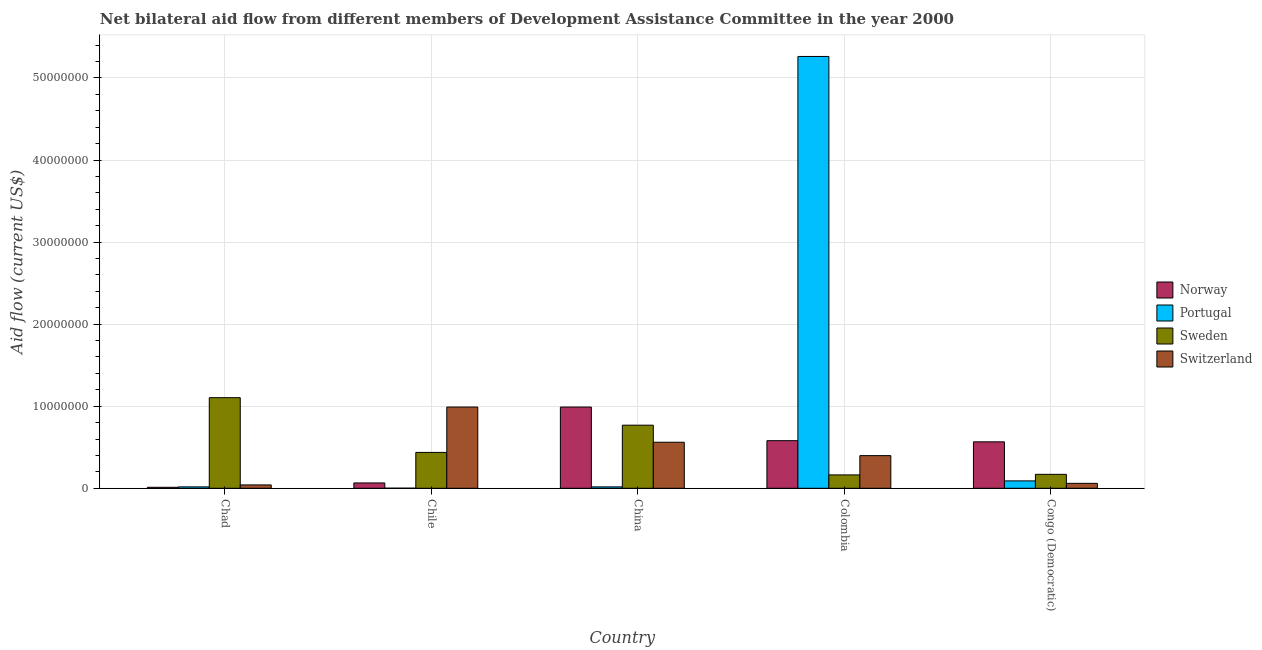How many different coloured bars are there?
Ensure brevity in your answer.  4. How many groups of bars are there?
Your answer should be very brief. 5. Are the number of bars on each tick of the X-axis equal?
Provide a short and direct response. Yes. How many bars are there on the 3rd tick from the right?
Your response must be concise. 4. What is the label of the 3rd group of bars from the left?
Offer a very short reply. China. What is the amount of aid given by portugal in Congo (Democratic)?
Your answer should be very brief. 9.00e+05. Across all countries, what is the maximum amount of aid given by sweden?
Ensure brevity in your answer.  1.10e+07. Across all countries, what is the minimum amount of aid given by switzerland?
Your answer should be compact. 4.10e+05. In which country was the amount of aid given by norway maximum?
Make the answer very short. China. In which country was the amount of aid given by switzerland minimum?
Ensure brevity in your answer.  Chad. What is the total amount of aid given by portugal in the graph?
Provide a succinct answer. 5.39e+07. What is the difference between the amount of aid given by norway in Chile and that in China?
Your answer should be very brief. -9.25e+06. What is the difference between the amount of aid given by norway in Chile and the amount of aid given by switzerland in Colombia?
Offer a terse response. -3.33e+06. What is the average amount of aid given by norway per country?
Provide a short and direct response. 4.43e+06. What is the difference between the amount of aid given by switzerland and amount of aid given by norway in China?
Your answer should be very brief. -4.29e+06. In how many countries, is the amount of aid given by switzerland greater than 22000000 US$?
Your answer should be compact. 0. What is the ratio of the amount of aid given by sweden in Chad to that in China?
Offer a very short reply. 1.44. Is the amount of aid given by portugal in Chad less than that in Congo (Democratic)?
Make the answer very short. Yes. Is the difference between the amount of aid given by portugal in Colombia and Congo (Democratic) greater than the difference between the amount of aid given by sweden in Colombia and Congo (Democratic)?
Ensure brevity in your answer.  Yes. What is the difference between the highest and the second highest amount of aid given by portugal?
Provide a short and direct response. 5.17e+07. What is the difference between the highest and the lowest amount of aid given by portugal?
Provide a short and direct response. 5.26e+07. In how many countries, is the amount of aid given by norway greater than the average amount of aid given by norway taken over all countries?
Give a very brief answer. 3. Is the sum of the amount of aid given by sweden in Chad and Congo (Democratic) greater than the maximum amount of aid given by norway across all countries?
Provide a succinct answer. Yes. What does the 4th bar from the left in China represents?
Provide a succinct answer. Switzerland. Is it the case that in every country, the sum of the amount of aid given by norway and amount of aid given by portugal is greater than the amount of aid given by sweden?
Keep it short and to the point. No. How many bars are there?
Give a very brief answer. 20. How many countries are there in the graph?
Ensure brevity in your answer.  5. Are the values on the major ticks of Y-axis written in scientific E-notation?
Ensure brevity in your answer.  No. Does the graph contain any zero values?
Ensure brevity in your answer.  No. What is the title of the graph?
Ensure brevity in your answer.  Net bilateral aid flow from different members of Development Assistance Committee in the year 2000. What is the label or title of the Y-axis?
Make the answer very short. Aid flow (current US$). What is the Aid flow (current US$) of Norway in Chad?
Ensure brevity in your answer.  1.20e+05. What is the Aid flow (current US$) in Portugal in Chad?
Offer a very short reply. 1.70e+05. What is the Aid flow (current US$) in Sweden in Chad?
Provide a succinct answer. 1.10e+07. What is the Aid flow (current US$) of Switzerland in Chad?
Your answer should be compact. 4.10e+05. What is the Aid flow (current US$) of Norway in Chile?
Provide a short and direct response. 6.50e+05. What is the Aid flow (current US$) in Portugal in Chile?
Your response must be concise. 10000. What is the Aid flow (current US$) of Sweden in Chile?
Give a very brief answer. 4.37e+06. What is the Aid flow (current US$) of Switzerland in Chile?
Offer a very short reply. 9.90e+06. What is the Aid flow (current US$) of Norway in China?
Your answer should be compact. 9.90e+06. What is the Aid flow (current US$) in Portugal in China?
Your response must be concise. 1.70e+05. What is the Aid flow (current US$) of Sweden in China?
Your answer should be compact. 7.69e+06. What is the Aid flow (current US$) of Switzerland in China?
Your response must be concise. 5.61e+06. What is the Aid flow (current US$) of Norway in Colombia?
Offer a very short reply. 5.80e+06. What is the Aid flow (current US$) of Portugal in Colombia?
Give a very brief answer. 5.26e+07. What is the Aid flow (current US$) in Sweden in Colombia?
Offer a very short reply. 1.63e+06. What is the Aid flow (current US$) of Switzerland in Colombia?
Offer a very short reply. 3.98e+06. What is the Aid flow (current US$) in Norway in Congo (Democratic)?
Provide a short and direct response. 5.66e+06. What is the Aid flow (current US$) of Sweden in Congo (Democratic)?
Ensure brevity in your answer.  1.70e+06. Across all countries, what is the maximum Aid flow (current US$) in Norway?
Provide a short and direct response. 9.90e+06. Across all countries, what is the maximum Aid flow (current US$) of Portugal?
Provide a succinct answer. 5.26e+07. Across all countries, what is the maximum Aid flow (current US$) in Sweden?
Ensure brevity in your answer.  1.10e+07. Across all countries, what is the maximum Aid flow (current US$) of Switzerland?
Offer a very short reply. 9.90e+06. Across all countries, what is the minimum Aid flow (current US$) in Sweden?
Offer a very short reply. 1.63e+06. Across all countries, what is the minimum Aid flow (current US$) in Switzerland?
Make the answer very short. 4.10e+05. What is the total Aid flow (current US$) of Norway in the graph?
Your response must be concise. 2.21e+07. What is the total Aid flow (current US$) of Portugal in the graph?
Ensure brevity in your answer.  5.39e+07. What is the total Aid flow (current US$) of Sweden in the graph?
Give a very brief answer. 2.64e+07. What is the total Aid flow (current US$) of Switzerland in the graph?
Provide a succinct answer. 2.05e+07. What is the difference between the Aid flow (current US$) in Norway in Chad and that in Chile?
Your response must be concise. -5.30e+05. What is the difference between the Aid flow (current US$) in Portugal in Chad and that in Chile?
Ensure brevity in your answer.  1.60e+05. What is the difference between the Aid flow (current US$) of Sweden in Chad and that in Chile?
Your answer should be compact. 6.67e+06. What is the difference between the Aid flow (current US$) of Switzerland in Chad and that in Chile?
Your response must be concise. -9.49e+06. What is the difference between the Aid flow (current US$) of Norway in Chad and that in China?
Provide a short and direct response. -9.78e+06. What is the difference between the Aid flow (current US$) of Sweden in Chad and that in China?
Your answer should be very brief. 3.35e+06. What is the difference between the Aid flow (current US$) in Switzerland in Chad and that in China?
Offer a very short reply. -5.20e+06. What is the difference between the Aid flow (current US$) in Norway in Chad and that in Colombia?
Make the answer very short. -5.68e+06. What is the difference between the Aid flow (current US$) of Portugal in Chad and that in Colombia?
Offer a terse response. -5.24e+07. What is the difference between the Aid flow (current US$) in Sweden in Chad and that in Colombia?
Offer a very short reply. 9.41e+06. What is the difference between the Aid flow (current US$) of Switzerland in Chad and that in Colombia?
Your answer should be compact. -3.57e+06. What is the difference between the Aid flow (current US$) of Norway in Chad and that in Congo (Democratic)?
Your answer should be compact. -5.54e+06. What is the difference between the Aid flow (current US$) in Portugal in Chad and that in Congo (Democratic)?
Provide a short and direct response. -7.30e+05. What is the difference between the Aid flow (current US$) in Sweden in Chad and that in Congo (Democratic)?
Offer a very short reply. 9.34e+06. What is the difference between the Aid flow (current US$) in Switzerland in Chad and that in Congo (Democratic)?
Make the answer very short. -1.90e+05. What is the difference between the Aid flow (current US$) of Norway in Chile and that in China?
Provide a short and direct response. -9.25e+06. What is the difference between the Aid flow (current US$) in Sweden in Chile and that in China?
Your response must be concise. -3.32e+06. What is the difference between the Aid flow (current US$) of Switzerland in Chile and that in China?
Your answer should be very brief. 4.29e+06. What is the difference between the Aid flow (current US$) of Norway in Chile and that in Colombia?
Your answer should be compact. -5.15e+06. What is the difference between the Aid flow (current US$) of Portugal in Chile and that in Colombia?
Ensure brevity in your answer.  -5.26e+07. What is the difference between the Aid flow (current US$) of Sweden in Chile and that in Colombia?
Give a very brief answer. 2.74e+06. What is the difference between the Aid flow (current US$) in Switzerland in Chile and that in Colombia?
Provide a short and direct response. 5.92e+06. What is the difference between the Aid flow (current US$) in Norway in Chile and that in Congo (Democratic)?
Your answer should be compact. -5.01e+06. What is the difference between the Aid flow (current US$) of Portugal in Chile and that in Congo (Democratic)?
Give a very brief answer. -8.90e+05. What is the difference between the Aid flow (current US$) of Sweden in Chile and that in Congo (Democratic)?
Your response must be concise. 2.67e+06. What is the difference between the Aid flow (current US$) in Switzerland in Chile and that in Congo (Democratic)?
Keep it short and to the point. 9.30e+06. What is the difference between the Aid flow (current US$) of Norway in China and that in Colombia?
Offer a terse response. 4.10e+06. What is the difference between the Aid flow (current US$) of Portugal in China and that in Colombia?
Your response must be concise. -5.24e+07. What is the difference between the Aid flow (current US$) in Sweden in China and that in Colombia?
Provide a succinct answer. 6.06e+06. What is the difference between the Aid flow (current US$) in Switzerland in China and that in Colombia?
Provide a succinct answer. 1.63e+06. What is the difference between the Aid flow (current US$) of Norway in China and that in Congo (Democratic)?
Give a very brief answer. 4.24e+06. What is the difference between the Aid flow (current US$) of Portugal in China and that in Congo (Democratic)?
Offer a very short reply. -7.30e+05. What is the difference between the Aid flow (current US$) in Sweden in China and that in Congo (Democratic)?
Keep it short and to the point. 5.99e+06. What is the difference between the Aid flow (current US$) in Switzerland in China and that in Congo (Democratic)?
Your answer should be very brief. 5.01e+06. What is the difference between the Aid flow (current US$) of Portugal in Colombia and that in Congo (Democratic)?
Offer a very short reply. 5.17e+07. What is the difference between the Aid flow (current US$) in Switzerland in Colombia and that in Congo (Democratic)?
Keep it short and to the point. 3.38e+06. What is the difference between the Aid flow (current US$) in Norway in Chad and the Aid flow (current US$) in Portugal in Chile?
Give a very brief answer. 1.10e+05. What is the difference between the Aid flow (current US$) of Norway in Chad and the Aid flow (current US$) of Sweden in Chile?
Give a very brief answer. -4.25e+06. What is the difference between the Aid flow (current US$) in Norway in Chad and the Aid flow (current US$) in Switzerland in Chile?
Give a very brief answer. -9.78e+06. What is the difference between the Aid flow (current US$) of Portugal in Chad and the Aid flow (current US$) of Sweden in Chile?
Offer a terse response. -4.20e+06. What is the difference between the Aid flow (current US$) in Portugal in Chad and the Aid flow (current US$) in Switzerland in Chile?
Keep it short and to the point. -9.73e+06. What is the difference between the Aid flow (current US$) of Sweden in Chad and the Aid flow (current US$) of Switzerland in Chile?
Make the answer very short. 1.14e+06. What is the difference between the Aid flow (current US$) of Norway in Chad and the Aid flow (current US$) of Portugal in China?
Your answer should be very brief. -5.00e+04. What is the difference between the Aid flow (current US$) of Norway in Chad and the Aid flow (current US$) of Sweden in China?
Your answer should be compact. -7.57e+06. What is the difference between the Aid flow (current US$) of Norway in Chad and the Aid flow (current US$) of Switzerland in China?
Provide a short and direct response. -5.49e+06. What is the difference between the Aid flow (current US$) of Portugal in Chad and the Aid flow (current US$) of Sweden in China?
Your response must be concise. -7.52e+06. What is the difference between the Aid flow (current US$) of Portugal in Chad and the Aid flow (current US$) of Switzerland in China?
Provide a short and direct response. -5.44e+06. What is the difference between the Aid flow (current US$) in Sweden in Chad and the Aid flow (current US$) in Switzerland in China?
Make the answer very short. 5.43e+06. What is the difference between the Aid flow (current US$) in Norway in Chad and the Aid flow (current US$) in Portugal in Colombia?
Give a very brief answer. -5.25e+07. What is the difference between the Aid flow (current US$) of Norway in Chad and the Aid flow (current US$) of Sweden in Colombia?
Give a very brief answer. -1.51e+06. What is the difference between the Aid flow (current US$) of Norway in Chad and the Aid flow (current US$) of Switzerland in Colombia?
Your answer should be very brief. -3.86e+06. What is the difference between the Aid flow (current US$) of Portugal in Chad and the Aid flow (current US$) of Sweden in Colombia?
Give a very brief answer. -1.46e+06. What is the difference between the Aid flow (current US$) in Portugal in Chad and the Aid flow (current US$) in Switzerland in Colombia?
Your response must be concise. -3.81e+06. What is the difference between the Aid flow (current US$) of Sweden in Chad and the Aid flow (current US$) of Switzerland in Colombia?
Ensure brevity in your answer.  7.06e+06. What is the difference between the Aid flow (current US$) of Norway in Chad and the Aid flow (current US$) of Portugal in Congo (Democratic)?
Offer a terse response. -7.80e+05. What is the difference between the Aid flow (current US$) in Norway in Chad and the Aid flow (current US$) in Sweden in Congo (Democratic)?
Your response must be concise. -1.58e+06. What is the difference between the Aid flow (current US$) of Norway in Chad and the Aid flow (current US$) of Switzerland in Congo (Democratic)?
Make the answer very short. -4.80e+05. What is the difference between the Aid flow (current US$) of Portugal in Chad and the Aid flow (current US$) of Sweden in Congo (Democratic)?
Provide a short and direct response. -1.53e+06. What is the difference between the Aid flow (current US$) of Portugal in Chad and the Aid flow (current US$) of Switzerland in Congo (Democratic)?
Ensure brevity in your answer.  -4.30e+05. What is the difference between the Aid flow (current US$) of Sweden in Chad and the Aid flow (current US$) of Switzerland in Congo (Democratic)?
Your response must be concise. 1.04e+07. What is the difference between the Aid flow (current US$) in Norway in Chile and the Aid flow (current US$) in Portugal in China?
Ensure brevity in your answer.  4.80e+05. What is the difference between the Aid flow (current US$) of Norway in Chile and the Aid flow (current US$) of Sweden in China?
Provide a short and direct response. -7.04e+06. What is the difference between the Aid flow (current US$) in Norway in Chile and the Aid flow (current US$) in Switzerland in China?
Ensure brevity in your answer.  -4.96e+06. What is the difference between the Aid flow (current US$) of Portugal in Chile and the Aid flow (current US$) of Sweden in China?
Your response must be concise. -7.68e+06. What is the difference between the Aid flow (current US$) of Portugal in Chile and the Aid flow (current US$) of Switzerland in China?
Provide a short and direct response. -5.60e+06. What is the difference between the Aid flow (current US$) in Sweden in Chile and the Aid flow (current US$) in Switzerland in China?
Your answer should be very brief. -1.24e+06. What is the difference between the Aid flow (current US$) in Norway in Chile and the Aid flow (current US$) in Portugal in Colombia?
Provide a succinct answer. -5.20e+07. What is the difference between the Aid flow (current US$) of Norway in Chile and the Aid flow (current US$) of Sweden in Colombia?
Ensure brevity in your answer.  -9.80e+05. What is the difference between the Aid flow (current US$) in Norway in Chile and the Aid flow (current US$) in Switzerland in Colombia?
Ensure brevity in your answer.  -3.33e+06. What is the difference between the Aid flow (current US$) in Portugal in Chile and the Aid flow (current US$) in Sweden in Colombia?
Offer a very short reply. -1.62e+06. What is the difference between the Aid flow (current US$) in Portugal in Chile and the Aid flow (current US$) in Switzerland in Colombia?
Your answer should be compact. -3.97e+06. What is the difference between the Aid flow (current US$) of Norway in Chile and the Aid flow (current US$) of Portugal in Congo (Democratic)?
Give a very brief answer. -2.50e+05. What is the difference between the Aid flow (current US$) of Norway in Chile and the Aid flow (current US$) of Sweden in Congo (Democratic)?
Provide a short and direct response. -1.05e+06. What is the difference between the Aid flow (current US$) of Portugal in Chile and the Aid flow (current US$) of Sweden in Congo (Democratic)?
Give a very brief answer. -1.69e+06. What is the difference between the Aid flow (current US$) in Portugal in Chile and the Aid flow (current US$) in Switzerland in Congo (Democratic)?
Offer a terse response. -5.90e+05. What is the difference between the Aid flow (current US$) of Sweden in Chile and the Aid flow (current US$) of Switzerland in Congo (Democratic)?
Offer a very short reply. 3.77e+06. What is the difference between the Aid flow (current US$) in Norway in China and the Aid flow (current US$) in Portugal in Colombia?
Your answer should be very brief. -4.27e+07. What is the difference between the Aid flow (current US$) of Norway in China and the Aid flow (current US$) of Sweden in Colombia?
Your answer should be very brief. 8.27e+06. What is the difference between the Aid flow (current US$) in Norway in China and the Aid flow (current US$) in Switzerland in Colombia?
Your response must be concise. 5.92e+06. What is the difference between the Aid flow (current US$) of Portugal in China and the Aid flow (current US$) of Sweden in Colombia?
Make the answer very short. -1.46e+06. What is the difference between the Aid flow (current US$) of Portugal in China and the Aid flow (current US$) of Switzerland in Colombia?
Ensure brevity in your answer.  -3.81e+06. What is the difference between the Aid flow (current US$) of Sweden in China and the Aid flow (current US$) of Switzerland in Colombia?
Your answer should be very brief. 3.71e+06. What is the difference between the Aid flow (current US$) in Norway in China and the Aid flow (current US$) in Portugal in Congo (Democratic)?
Ensure brevity in your answer.  9.00e+06. What is the difference between the Aid flow (current US$) in Norway in China and the Aid flow (current US$) in Sweden in Congo (Democratic)?
Your response must be concise. 8.20e+06. What is the difference between the Aid flow (current US$) of Norway in China and the Aid flow (current US$) of Switzerland in Congo (Democratic)?
Provide a short and direct response. 9.30e+06. What is the difference between the Aid flow (current US$) of Portugal in China and the Aid flow (current US$) of Sweden in Congo (Democratic)?
Your answer should be very brief. -1.53e+06. What is the difference between the Aid flow (current US$) in Portugal in China and the Aid flow (current US$) in Switzerland in Congo (Democratic)?
Provide a succinct answer. -4.30e+05. What is the difference between the Aid flow (current US$) in Sweden in China and the Aid flow (current US$) in Switzerland in Congo (Democratic)?
Your response must be concise. 7.09e+06. What is the difference between the Aid flow (current US$) in Norway in Colombia and the Aid flow (current US$) in Portugal in Congo (Democratic)?
Offer a very short reply. 4.90e+06. What is the difference between the Aid flow (current US$) of Norway in Colombia and the Aid flow (current US$) of Sweden in Congo (Democratic)?
Provide a succinct answer. 4.10e+06. What is the difference between the Aid flow (current US$) of Norway in Colombia and the Aid flow (current US$) of Switzerland in Congo (Democratic)?
Your answer should be very brief. 5.20e+06. What is the difference between the Aid flow (current US$) in Portugal in Colombia and the Aid flow (current US$) in Sweden in Congo (Democratic)?
Your response must be concise. 5.09e+07. What is the difference between the Aid flow (current US$) in Portugal in Colombia and the Aid flow (current US$) in Switzerland in Congo (Democratic)?
Make the answer very short. 5.20e+07. What is the difference between the Aid flow (current US$) in Sweden in Colombia and the Aid flow (current US$) in Switzerland in Congo (Democratic)?
Offer a terse response. 1.03e+06. What is the average Aid flow (current US$) of Norway per country?
Provide a succinct answer. 4.43e+06. What is the average Aid flow (current US$) of Portugal per country?
Offer a very short reply. 1.08e+07. What is the average Aid flow (current US$) of Sweden per country?
Your response must be concise. 5.29e+06. What is the average Aid flow (current US$) of Switzerland per country?
Your response must be concise. 4.10e+06. What is the difference between the Aid flow (current US$) of Norway and Aid flow (current US$) of Portugal in Chad?
Keep it short and to the point. -5.00e+04. What is the difference between the Aid flow (current US$) in Norway and Aid flow (current US$) in Sweden in Chad?
Offer a very short reply. -1.09e+07. What is the difference between the Aid flow (current US$) in Portugal and Aid flow (current US$) in Sweden in Chad?
Your answer should be compact. -1.09e+07. What is the difference between the Aid flow (current US$) of Portugal and Aid flow (current US$) of Switzerland in Chad?
Your response must be concise. -2.40e+05. What is the difference between the Aid flow (current US$) in Sweden and Aid flow (current US$) in Switzerland in Chad?
Offer a very short reply. 1.06e+07. What is the difference between the Aid flow (current US$) in Norway and Aid flow (current US$) in Portugal in Chile?
Your answer should be compact. 6.40e+05. What is the difference between the Aid flow (current US$) in Norway and Aid flow (current US$) in Sweden in Chile?
Your answer should be very brief. -3.72e+06. What is the difference between the Aid flow (current US$) in Norway and Aid flow (current US$) in Switzerland in Chile?
Your response must be concise. -9.25e+06. What is the difference between the Aid flow (current US$) of Portugal and Aid flow (current US$) of Sweden in Chile?
Give a very brief answer. -4.36e+06. What is the difference between the Aid flow (current US$) in Portugal and Aid flow (current US$) in Switzerland in Chile?
Provide a short and direct response. -9.89e+06. What is the difference between the Aid flow (current US$) of Sweden and Aid flow (current US$) of Switzerland in Chile?
Give a very brief answer. -5.53e+06. What is the difference between the Aid flow (current US$) in Norway and Aid flow (current US$) in Portugal in China?
Offer a very short reply. 9.73e+06. What is the difference between the Aid flow (current US$) of Norway and Aid flow (current US$) of Sweden in China?
Keep it short and to the point. 2.21e+06. What is the difference between the Aid flow (current US$) in Norway and Aid flow (current US$) in Switzerland in China?
Make the answer very short. 4.29e+06. What is the difference between the Aid flow (current US$) of Portugal and Aid flow (current US$) of Sweden in China?
Offer a terse response. -7.52e+06. What is the difference between the Aid flow (current US$) in Portugal and Aid flow (current US$) in Switzerland in China?
Offer a very short reply. -5.44e+06. What is the difference between the Aid flow (current US$) in Sweden and Aid flow (current US$) in Switzerland in China?
Make the answer very short. 2.08e+06. What is the difference between the Aid flow (current US$) in Norway and Aid flow (current US$) in Portugal in Colombia?
Provide a succinct answer. -4.68e+07. What is the difference between the Aid flow (current US$) of Norway and Aid flow (current US$) of Sweden in Colombia?
Ensure brevity in your answer.  4.17e+06. What is the difference between the Aid flow (current US$) in Norway and Aid flow (current US$) in Switzerland in Colombia?
Offer a very short reply. 1.82e+06. What is the difference between the Aid flow (current US$) of Portugal and Aid flow (current US$) of Sweden in Colombia?
Offer a very short reply. 5.10e+07. What is the difference between the Aid flow (current US$) in Portugal and Aid flow (current US$) in Switzerland in Colombia?
Your answer should be very brief. 4.86e+07. What is the difference between the Aid flow (current US$) of Sweden and Aid flow (current US$) of Switzerland in Colombia?
Provide a succinct answer. -2.35e+06. What is the difference between the Aid flow (current US$) of Norway and Aid flow (current US$) of Portugal in Congo (Democratic)?
Your answer should be very brief. 4.76e+06. What is the difference between the Aid flow (current US$) of Norway and Aid flow (current US$) of Sweden in Congo (Democratic)?
Offer a terse response. 3.96e+06. What is the difference between the Aid flow (current US$) of Norway and Aid flow (current US$) of Switzerland in Congo (Democratic)?
Provide a succinct answer. 5.06e+06. What is the difference between the Aid flow (current US$) of Portugal and Aid flow (current US$) of Sweden in Congo (Democratic)?
Offer a very short reply. -8.00e+05. What is the difference between the Aid flow (current US$) of Sweden and Aid flow (current US$) of Switzerland in Congo (Democratic)?
Your answer should be compact. 1.10e+06. What is the ratio of the Aid flow (current US$) of Norway in Chad to that in Chile?
Keep it short and to the point. 0.18. What is the ratio of the Aid flow (current US$) of Portugal in Chad to that in Chile?
Your answer should be very brief. 17. What is the ratio of the Aid flow (current US$) in Sweden in Chad to that in Chile?
Ensure brevity in your answer.  2.53. What is the ratio of the Aid flow (current US$) in Switzerland in Chad to that in Chile?
Make the answer very short. 0.04. What is the ratio of the Aid flow (current US$) of Norway in Chad to that in China?
Provide a succinct answer. 0.01. What is the ratio of the Aid flow (current US$) in Portugal in Chad to that in China?
Make the answer very short. 1. What is the ratio of the Aid flow (current US$) in Sweden in Chad to that in China?
Keep it short and to the point. 1.44. What is the ratio of the Aid flow (current US$) in Switzerland in Chad to that in China?
Give a very brief answer. 0.07. What is the ratio of the Aid flow (current US$) of Norway in Chad to that in Colombia?
Offer a terse response. 0.02. What is the ratio of the Aid flow (current US$) in Portugal in Chad to that in Colombia?
Make the answer very short. 0. What is the ratio of the Aid flow (current US$) in Sweden in Chad to that in Colombia?
Offer a very short reply. 6.77. What is the ratio of the Aid flow (current US$) in Switzerland in Chad to that in Colombia?
Provide a succinct answer. 0.1. What is the ratio of the Aid flow (current US$) of Norway in Chad to that in Congo (Democratic)?
Keep it short and to the point. 0.02. What is the ratio of the Aid flow (current US$) of Portugal in Chad to that in Congo (Democratic)?
Provide a short and direct response. 0.19. What is the ratio of the Aid flow (current US$) in Sweden in Chad to that in Congo (Democratic)?
Your answer should be compact. 6.49. What is the ratio of the Aid flow (current US$) in Switzerland in Chad to that in Congo (Democratic)?
Your answer should be very brief. 0.68. What is the ratio of the Aid flow (current US$) in Norway in Chile to that in China?
Your answer should be compact. 0.07. What is the ratio of the Aid flow (current US$) in Portugal in Chile to that in China?
Ensure brevity in your answer.  0.06. What is the ratio of the Aid flow (current US$) of Sweden in Chile to that in China?
Offer a very short reply. 0.57. What is the ratio of the Aid flow (current US$) of Switzerland in Chile to that in China?
Your answer should be very brief. 1.76. What is the ratio of the Aid flow (current US$) of Norway in Chile to that in Colombia?
Offer a very short reply. 0.11. What is the ratio of the Aid flow (current US$) of Sweden in Chile to that in Colombia?
Give a very brief answer. 2.68. What is the ratio of the Aid flow (current US$) in Switzerland in Chile to that in Colombia?
Keep it short and to the point. 2.49. What is the ratio of the Aid flow (current US$) of Norway in Chile to that in Congo (Democratic)?
Give a very brief answer. 0.11. What is the ratio of the Aid flow (current US$) of Portugal in Chile to that in Congo (Democratic)?
Provide a short and direct response. 0.01. What is the ratio of the Aid flow (current US$) in Sweden in Chile to that in Congo (Democratic)?
Your response must be concise. 2.57. What is the ratio of the Aid flow (current US$) of Norway in China to that in Colombia?
Your response must be concise. 1.71. What is the ratio of the Aid flow (current US$) of Portugal in China to that in Colombia?
Provide a succinct answer. 0. What is the ratio of the Aid flow (current US$) of Sweden in China to that in Colombia?
Your answer should be very brief. 4.72. What is the ratio of the Aid flow (current US$) in Switzerland in China to that in Colombia?
Your response must be concise. 1.41. What is the ratio of the Aid flow (current US$) of Norway in China to that in Congo (Democratic)?
Provide a short and direct response. 1.75. What is the ratio of the Aid flow (current US$) in Portugal in China to that in Congo (Democratic)?
Your response must be concise. 0.19. What is the ratio of the Aid flow (current US$) of Sweden in China to that in Congo (Democratic)?
Ensure brevity in your answer.  4.52. What is the ratio of the Aid flow (current US$) in Switzerland in China to that in Congo (Democratic)?
Ensure brevity in your answer.  9.35. What is the ratio of the Aid flow (current US$) of Norway in Colombia to that in Congo (Democratic)?
Your response must be concise. 1.02. What is the ratio of the Aid flow (current US$) of Portugal in Colombia to that in Congo (Democratic)?
Your answer should be compact. 58.47. What is the ratio of the Aid flow (current US$) of Sweden in Colombia to that in Congo (Democratic)?
Your response must be concise. 0.96. What is the ratio of the Aid flow (current US$) in Switzerland in Colombia to that in Congo (Democratic)?
Keep it short and to the point. 6.63. What is the difference between the highest and the second highest Aid flow (current US$) in Norway?
Make the answer very short. 4.10e+06. What is the difference between the highest and the second highest Aid flow (current US$) of Portugal?
Give a very brief answer. 5.17e+07. What is the difference between the highest and the second highest Aid flow (current US$) of Sweden?
Your answer should be compact. 3.35e+06. What is the difference between the highest and the second highest Aid flow (current US$) of Switzerland?
Ensure brevity in your answer.  4.29e+06. What is the difference between the highest and the lowest Aid flow (current US$) in Norway?
Provide a succinct answer. 9.78e+06. What is the difference between the highest and the lowest Aid flow (current US$) in Portugal?
Provide a succinct answer. 5.26e+07. What is the difference between the highest and the lowest Aid flow (current US$) of Sweden?
Keep it short and to the point. 9.41e+06. What is the difference between the highest and the lowest Aid flow (current US$) of Switzerland?
Ensure brevity in your answer.  9.49e+06. 